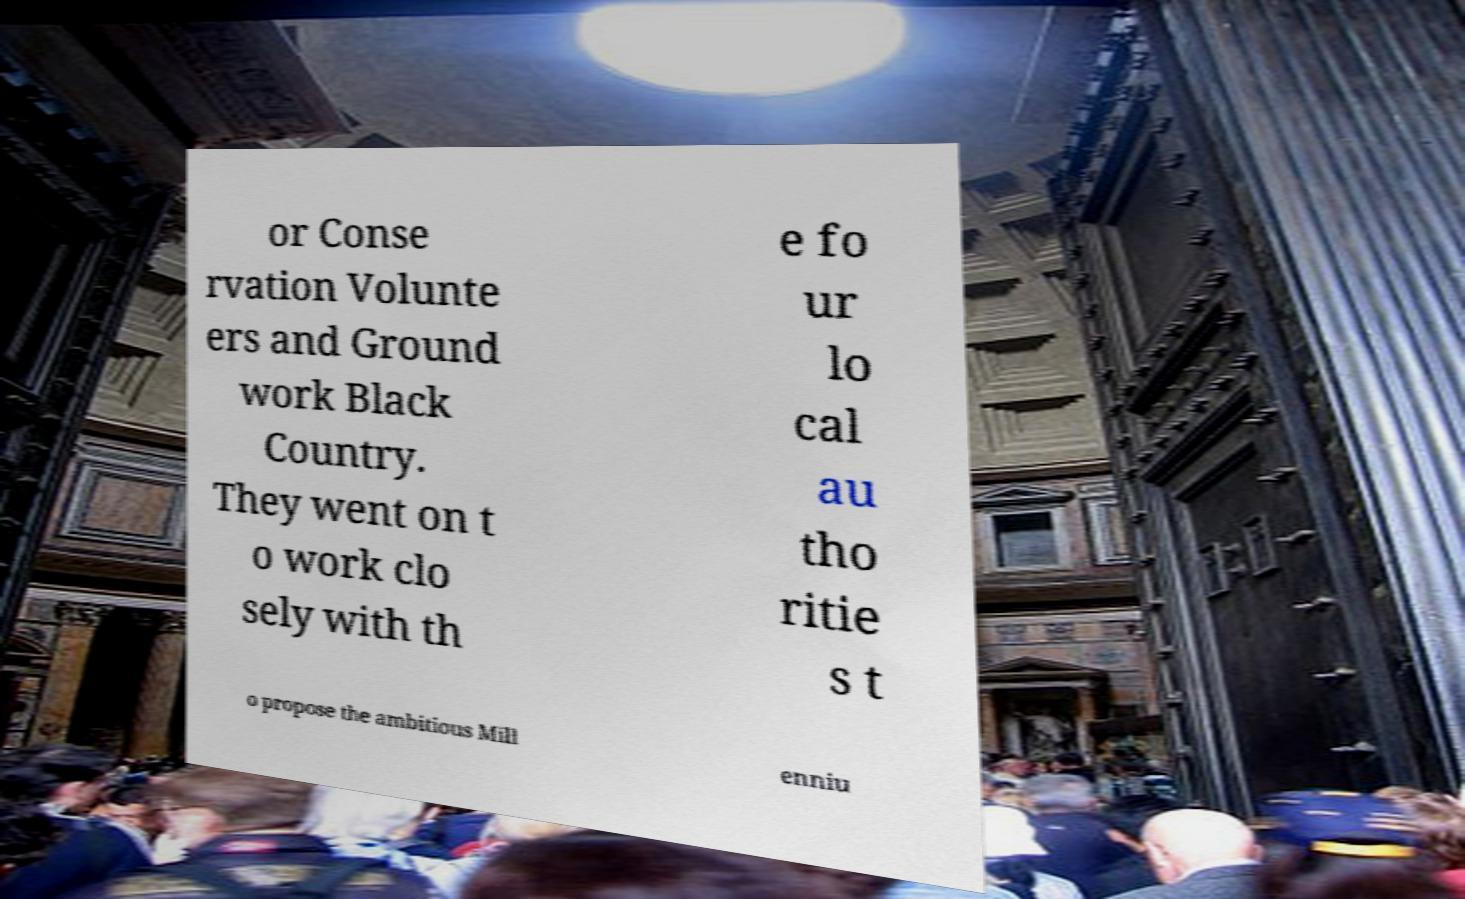What messages or text are displayed in this image? I need them in a readable, typed format. or Conse rvation Volunte ers and Ground work Black Country. They went on t o work clo sely with th e fo ur lo cal au tho ritie s t o propose the ambitious Mill enniu 